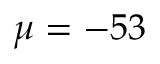<formula> <loc_0><loc_0><loc_500><loc_500>\mu = - 5 3</formula> 